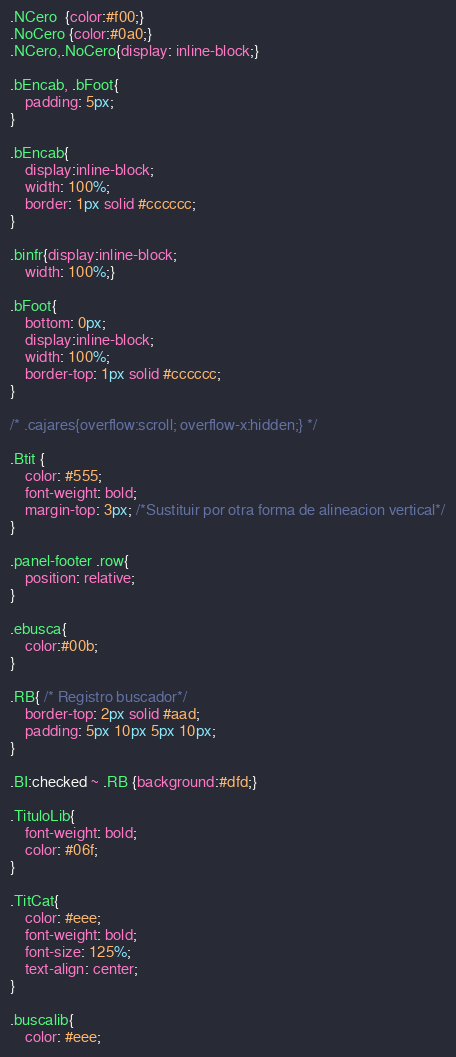<code> <loc_0><loc_0><loc_500><loc_500><_CSS_>.NCero  {color:#f00;}
.NoCero {color:#0a0;}
.NCero,.NoCero{display: inline-block;}

.bEncab, .bFoot{
	padding: 5px;
}

.bEncab{
	display:inline-block;
	width: 100%;
	border: 1px solid #cccccc;
}

.binfr{display:inline-block;
	width: 100%;}

.bFoot{
	bottom: 0px;
	display:inline-block;
	width: 100%;
	border-top: 1px solid #cccccc;
}

/* .cajares{overflow:scroll; overflow-x:hidden;} */

.Btit {
	color: #555;
	font-weight: bold;
	margin-top: 3px; /*Sustituir por otra forma de alineacion vertical*/
}

.panel-footer .row{
	position: relative;
}

.ebusca{
	color:#00b;
}

.RB{ /* Registro buscador*/
	border-top: 2px solid #aad;
	padding: 5px 10px 5px 10px;
}

.BI:checked ~ .RB {background:#dfd;}

.TituloLib{
	font-weight: bold;
	color: #06f;
}

.TitCat{
	color: #eee;
	font-weight: bold;
	font-size: 125%;
	text-align: center;
}

.buscalib{
	color: #eee;</code> 